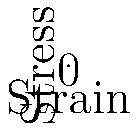As a CEO concerned with the structural integrity of data centers, which material represented in the stress-strain curve would be most suitable for constructing load-bearing elements in a region prone to sudden stress spikes, and why? To answer this question, we need to analyze the stress-strain curves for the three materials shown:

1. Steel (blue curve): Shows a linear relationship between stress and strain, indicating elastic behavior. This suggests:
   - Predictable deformation under stress
   - High strength and stiffness
   - Ability to return to original shape after stress removal (within elastic limit)

2. Concrete (red curve): Exhibits a non-linear relationship with a decreasing slope, indicating:
   - Initial stiffness followed by decreased resistance to deformation
   - Potential for brittle failure under sudden stress

3. Polymer (green curve): Displays a logarithmic relationship, suggesting:
   - High initial deformation under low stress
   - Increasing resistance to deformation at higher stress levels
   - Potential for energy absorption

For a region prone to sudden stress spikes:

1. Steel would be the most suitable material because:
   - Its linear stress-strain relationship allows for predictable behavior under varying loads
   - High strength and stiffness can withstand sudden stress spikes without significant deformation
   - Elastic behavior ensures the structure can return to its original shape after stress removal

2. Concrete, while strong, might be prone to brittle failure under sudden stress spikes, making it less ideal.

3. Polymers, although good at energy absorption, may deform too much under initial stress, potentially compromising structural integrity.

In the context of data centers, where structural stability is crucial for protecting sensitive equipment, steel's predictable behavior and ability to withstand sudden loads make it the optimal choice among the given materials.
Answer: Steel, due to its linear stress-strain relationship, high strength, and elastic behavior. 